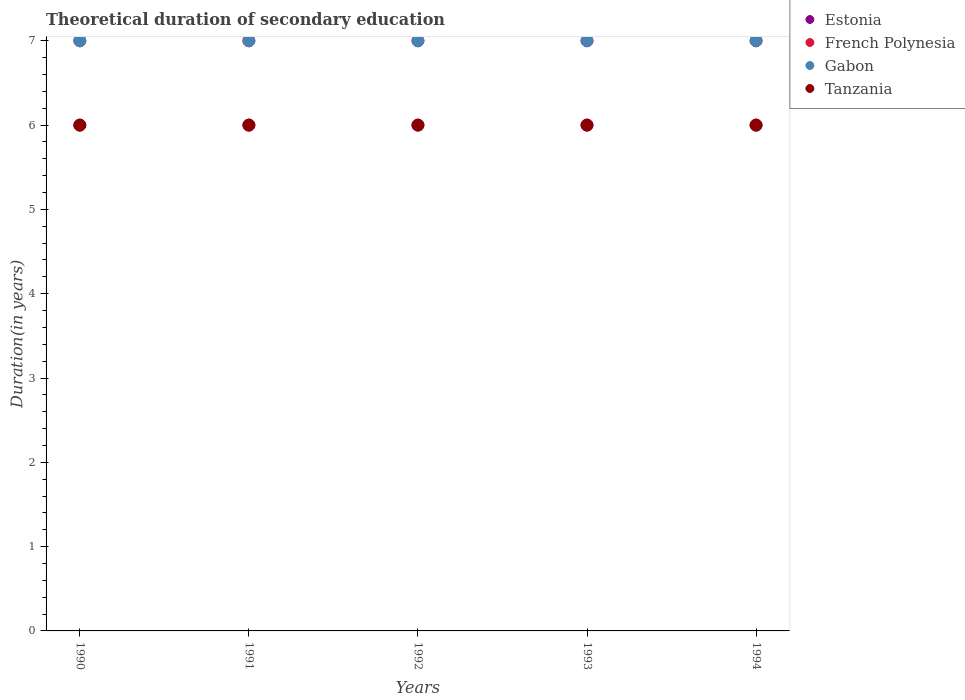How many different coloured dotlines are there?
Offer a terse response. 4. What is the total theoretical duration of secondary education in French Polynesia in 1992?
Offer a terse response. 7. Across all years, what is the minimum total theoretical duration of secondary education in Gabon?
Provide a short and direct response. 7. In which year was the total theoretical duration of secondary education in Tanzania minimum?
Your answer should be very brief. 1990. What is the total total theoretical duration of secondary education in Tanzania in the graph?
Offer a terse response. 30. What is the difference between the total theoretical duration of secondary education in Gabon in 1991 and the total theoretical duration of secondary education in French Polynesia in 1990?
Offer a terse response. 0. What is the average total theoretical duration of secondary education in Tanzania per year?
Your answer should be very brief. 6. In the year 1992, what is the difference between the total theoretical duration of secondary education in Gabon and total theoretical duration of secondary education in Tanzania?
Offer a terse response. 1. Is the difference between the total theoretical duration of secondary education in Gabon in 1990 and 1992 greater than the difference between the total theoretical duration of secondary education in Tanzania in 1990 and 1992?
Your answer should be very brief. No. What is the difference between the highest and the second highest total theoretical duration of secondary education in French Polynesia?
Your answer should be compact. 0. What is the difference between the highest and the lowest total theoretical duration of secondary education in Tanzania?
Give a very brief answer. 0. Is the sum of the total theoretical duration of secondary education in Gabon in 1991 and 1992 greater than the maximum total theoretical duration of secondary education in Estonia across all years?
Provide a succinct answer. Yes. Is it the case that in every year, the sum of the total theoretical duration of secondary education in Gabon and total theoretical duration of secondary education in Tanzania  is greater than the sum of total theoretical duration of secondary education in Estonia and total theoretical duration of secondary education in French Polynesia?
Offer a very short reply. Yes. Is the total theoretical duration of secondary education in French Polynesia strictly less than the total theoretical duration of secondary education in Gabon over the years?
Provide a short and direct response. No. How many years are there in the graph?
Offer a very short reply. 5. Does the graph contain any zero values?
Your answer should be very brief. No. Does the graph contain grids?
Give a very brief answer. No. Where does the legend appear in the graph?
Provide a succinct answer. Top right. How many legend labels are there?
Offer a very short reply. 4. How are the legend labels stacked?
Your answer should be very brief. Vertical. What is the title of the graph?
Provide a succinct answer. Theoretical duration of secondary education. What is the label or title of the Y-axis?
Provide a succinct answer. Duration(in years). What is the Duration(in years) of French Polynesia in 1990?
Provide a succinct answer. 7. What is the Duration(in years) of Gabon in 1990?
Make the answer very short. 7. What is the Duration(in years) in Tanzania in 1990?
Offer a terse response. 6. What is the Duration(in years) of Estonia in 1991?
Offer a very short reply. 6. What is the Duration(in years) in French Polynesia in 1991?
Offer a terse response. 7. What is the Duration(in years) in Tanzania in 1992?
Provide a short and direct response. 6. What is the Duration(in years) of Tanzania in 1994?
Offer a very short reply. 6. Across all years, what is the maximum Duration(in years) in Estonia?
Provide a succinct answer. 6. Across all years, what is the maximum Duration(in years) in French Polynesia?
Your response must be concise. 7. Across all years, what is the minimum Duration(in years) of French Polynesia?
Provide a succinct answer. 7. Across all years, what is the minimum Duration(in years) in Gabon?
Make the answer very short. 7. What is the total Duration(in years) of Estonia in the graph?
Your response must be concise. 30. What is the total Duration(in years) in Gabon in the graph?
Provide a succinct answer. 35. What is the total Duration(in years) in Tanzania in the graph?
Offer a very short reply. 30. What is the difference between the Duration(in years) of Gabon in 1990 and that in 1992?
Your response must be concise. 0. What is the difference between the Duration(in years) in Gabon in 1990 and that in 1993?
Offer a very short reply. 0. What is the difference between the Duration(in years) of Tanzania in 1990 and that in 1993?
Offer a very short reply. 0. What is the difference between the Duration(in years) of French Polynesia in 1990 and that in 1994?
Make the answer very short. 0. What is the difference between the Duration(in years) in Gabon in 1990 and that in 1994?
Ensure brevity in your answer.  0. What is the difference between the Duration(in years) of Tanzania in 1991 and that in 1992?
Make the answer very short. 0. What is the difference between the Duration(in years) of Tanzania in 1991 and that in 1993?
Offer a very short reply. 0. What is the difference between the Duration(in years) of Gabon in 1991 and that in 1994?
Offer a very short reply. 0. What is the difference between the Duration(in years) in Estonia in 1992 and that in 1993?
Your response must be concise. 0. What is the difference between the Duration(in years) in French Polynesia in 1992 and that in 1993?
Provide a succinct answer. 0. What is the difference between the Duration(in years) in Estonia in 1990 and the Duration(in years) in Tanzania in 1991?
Your answer should be compact. 0. What is the difference between the Duration(in years) in French Polynesia in 1990 and the Duration(in years) in Tanzania in 1991?
Your response must be concise. 1. What is the difference between the Duration(in years) in Estonia in 1990 and the Duration(in years) in Gabon in 1992?
Your answer should be very brief. -1. What is the difference between the Duration(in years) of French Polynesia in 1990 and the Duration(in years) of Gabon in 1992?
Provide a short and direct response. 0. What is the difference between the Duration(in years) in French Polynesia in 1990 and the Duration(in years) in Tanzania in 1992?
Offer a terse response. 1. What is the difference between the Duration(in years) of Gabon in 1990 and the Duration(in years) of Tanzania in 1993?
Your response must be concise. 1. What is the difference between the Duration(in years) in French Polynesia in 1990 and the Duration(in years) in Gabon in 1994?
Provide a short and direct response. 0. What is the difference between the Duration(in years) of French Polynesia in 1990 and the Duration(in years) of Tanzania in 1994?
Ensure brevity in your answer.  1. What is the difference between the Duration(in years) of Estonia in 1991 and the Duration(in years) of French Polynesia in 1992?
Give a very brief answer. -1. What is the difference between the Duration(in years) of Estonia in 1991 and the Duration(in years) of Gabon in 1992?
Offer a terse response. -1. What is the difference between the Duration(in years) of French Polynesia in 1991 and the Duration(in years) of Gabon in 1992?
Ensure brevity in your answer.  0. What is the difference between the Duration(in years) of Gabon in 1991 and the Duration(in years) of Tanzania in 1992?
Offer a terse response. 1. What is the difference between the Duration(in years) in Estonia in 1991 and the Duration(in years) in French Polynesia in 1993?
Provide a succinct answer. -1. What is the difference between the Duration(in years) of Estonia in 1991 and the Duration(in years) of Tanzania in 1993?
Offer a terse response. 0. What is the difference between the Duration(in years) of French Polynesia in 1991 and the Duration(in years) of Tanzania in 1993?
Offer a terse response. 1. What is the difference between the Duration(in years) in Gabon in 1991 and the Duration(in years) in Tanzania in 1993?
Your response must be concise. 1. What is the difference between the Duration(in years) in Estonia in 1991 and the Duration(in years) in French Polynesia in 1994?
Provide a short and direct response. -1. What is the difference between the Duration(in years) of French Polynesia in 1991 and the Duration(in years) of Tanzania in 1994?
Your answer should be compact. 1. What is the difference between the Duration(in years) in Estonia in 1992 and the Duration(in years) in French Polynesia in 1993?
Your response must be concise. -1. What is the difference between the Duration(in years) in Estonia in 1992 and the Duration(in years) in Gabon in 1993?
Provide a short and direct response. -1. What is the difference between the Duration(in years) of Estonia in 1992 and the Duration(in years) of Tanzania in 1993?
Your response must be concise. 0. What is the difference between the Duration(in years) of French Polynesia in 1992 and the Duration(in years) of Gabon in 1993?
Your answer should be very brief. 0. What is the difference between the Duration(in years) of French Polynesia in 1992 and the Duration(in years) of Tanzania in 1993?
Keep it short and to the point. 1. What is the difference between the Duration(in years) of Estonia in 1992 and the Duration(in years) of French Polynesia in 1994?
Provide a short and direct response. -1. What is the difference between the Duration(in years) in French Polynesia in 1992 and the Duration(in years) in Gabon in 1994?
Ensure brevity in your answer.  0. What is the difference between the Duration(in years) in French Polynesia in 1992 and the Duration(in years) in Tanzania in 1994?
Keep it short and to the point. 1. What is the difference between the Duration(in years) of Gabon in 1992 and the Duration(in years) of Tanzania in 1994?
Offer a terse response. 1. What is the difference between the Duration(in years) in Estonia in 1993 and the Duration(in years) in French Polynesia in 1994?
Ensure brevity in your answer.  -1. What is the difference between the Duration(in years) of Estonia in 1993 and the Duration(in years) of Gabon in 1994?
Make the answer very short. -1. What is the difference between the Duration(in years) of Estonia in 1993 and the Duration(in years) of Tanzania in 1994?
Ensure brevity in your answer.  0. What is the difference between the Duration(in years) of French Polynesia in 1993 and the Duration(in years) of Gabon in 1994?
Give a very brief answer. 0. What is the difference between the Duration(in years) in Gabon in 1993 and the Duration(in years) in Tanzania in 1994?
Your answer should be very brief. 1. What is the average Duration(in years) in Estonia per year?
Keep it short and to the point. 6. In the year 1990, what is the difference between the Duration(in years) in Estonia and Duration(in years) in French Polynesia?
Provide a short and direct response. -1. In the year 1990, what is the difference between the Duration(in years) of French Polynesia and Duration(in years) of Gabon?
Keep it short and to the point. 0. In the year 1990, what is the difference between the Duration(in years) in Gabon and Duration(in years) in Tanzania?
Offer a very short reply. 1. In the year 1991, what is the difference between the Duration(in years) of Estonia and Duration(in years) of Gabon?
Your answer should be compact. -1. In the year 1991, what is the difference between the Duration(in years) of Estonia and Duration(in years) of Tanzania?
Ensure brevity in your answer.  0. In the year 1991, what is the difference between the Duration(in years) of French Polynesia and Duration(in years) of Gabon?
Keep it short and to the point. 0. In the year 1992, what is the difference between the Duration(in years) of Estonia and Duration(in years) of French Polynesia?
Provide a short and direct response. -1. In the year 1992, what is the difference between the Duration(in years) of French Polynesia and Duration(in years) of Gabon?
Your answer should be compact. 0. In the year 1992, what is the difference between the Duration(in years) in Gabon and Duration(in years) in Tanzania?
Ensure brevity in your answer.  1. In the year 1993, what is the difference between the Duration(in years) of Estonia and Duration(in years) of French Polynesia?
Ensure brevity in your answer.  -1. In the year 1993, what is the difference between the Duration(in years) in Estonia and Duration(in years) in Tanzania?
Your answer should be very brief. 0. In the year 1993, what is the difference between the Duration(in years) in French Polynesia and Duration(in years) in Gabon?
Make the answer very short. 0. In the year 1994, what is the difference between the Duration(in years) in Estonia and Duration(in years) in Gabon?
Your response must be concise. -1. In the year 1994, what is the difference between the Duration(in years) in French Polynesia and Duration(in years) in Gabon?
Ensure brevity in your answer.  0. What is the ratio of the Duration(in years) of Tanzania in 1990 to that in 1991?
Provide a succinct answer. 1. What is the ratio of the Duration(in years) in Tanzania in 1990 to that in 1992?
Make the answer very short. 1. What is the ratio of the Duration(in years) of French Polynesia in 1990 to that in 1993?
Provide a succinct answer. 1. What is the ratio of the Duration(in years) in Tanzania in 1990 to that in 1993?
Provide a succinct answer. 1. What is the ratio of the Duration(in years) of Estonia in 1990 to that in 1994?
Provide a short and direct response. 1. What is the ratio of the Duration(in years) of Estonia in 1991 to that in 1992?
Your answer should be compact. 1. What is the ratio of the Duration(in years) in French Polynesia in 1991 to that in 1992?
Make the answer very short. 1. What is the ratio of the Duration(in years) of Gabon in 1991 to that in 1992?
Keep it short and to the point. 1. What is the ratio of the Duration(in years) of Gabon in 1991 to that in 1993?
Your answer should be very brief. 1. What is the ratio of the Duration(in years) in Tanzania in 1991 to that in 1993?
Provide a short and direct response. 1. What is the ratio of the Duration(in years) in Estonia in 1991 to that in 1994?
Make the answer very short. 1. What is the ratio of the Duration(in years) of Estonia in 1992 to that in 1993?
Give a very brief answer. 1. What is the ratio of the Duration(in years) of French Polynesia in 1992 to that in 1993?
Your response must be concise. 1. What is the ratio of the Duration(in years) of Gabon in 1992 to that in 1993?
Your response must be concise. 1. What is the ratio of the Duration(in years) in French Polynesia in 1992 to that in 1994?
Your answer should be very brief. 1. What is the ratio of the Duration(in years) of Gabon in 1992 to that in 1994?
Give a very brief answer. 1. What is the ratio of the Duration(in years) in Tanzania in 1992 to that in 1994?
Your answer should be compact. 1. What is the ratio of the Duration(in years) of Estonia in 1993 to that in 1994?
Offer a very short reply. 1. What is the ratio of the Duration(in years) of Gabon in 1993 to that in 1994?
Your answer should be very brief. 1. What is the ratio of the Duration(in years) in Tanzania in 1993 to that in 1994?
Give a very brief answer. 1. What is the difference between the highest and the second highest Duration(in years) in Gabon?
Ensure brevity in your answer.  0. What is the difference between the highest and the lowest Duration(in years) in Estonia?
Keep it short and to the point. 0. What is the difference between the highest and the lowest Duration(in years) in French Polynesia?
Your response must be concise. 0. What is the difference between the highest and the lowest Duration(in years) in Gabon?
Offer a very short reply. 0. 